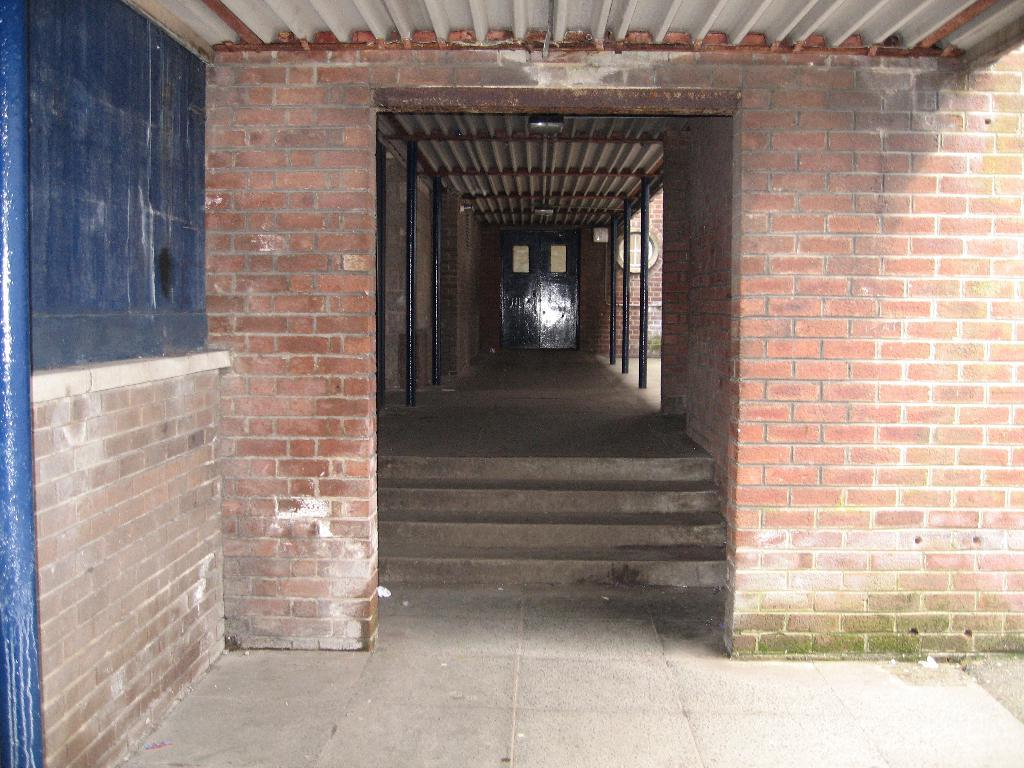What is located on the left side of the image? There is a board on the left side of the image. What is the board attached to? The board is attached to a brick wall. What type of structure is the brick wall part of? The brick wall is part of a building. Can you describe the building in the image? The building has a roof, steps, a floor, and poles. Is there any entrance visible in the image? Yes, there is a door visible in the background of the image. How many wounds can be seen on the goat in the image? There is no goat present in the image, so it is not possible to determine the number of wounds. 